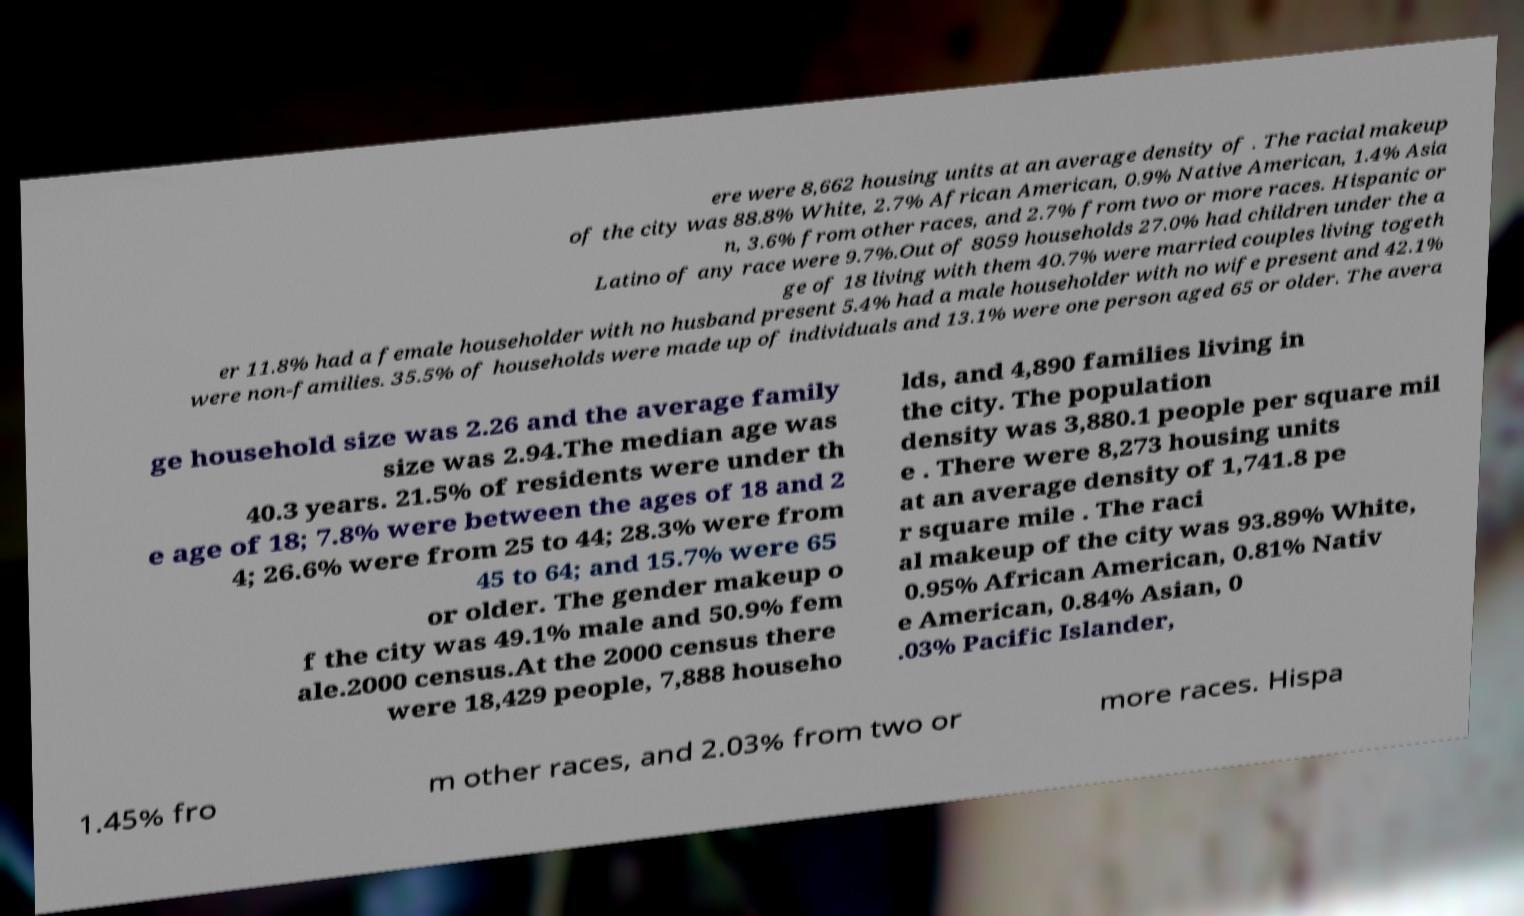What messages or text are displayed in this image? I need them in a readable, typed format. ere were 8,662 housing units at an average density of . The racial makeup of the city was 88.8% White, 2.7% African American, 0.9% Native American, 1.4% Asia n, 3.6% from other races, and 2.7% from two or more races. Hispanic or Latino of any race were 9.7%.Out of 8059 households 27.0% had children under the a ge of 18 living with them 40.7% were married couples living togeth er 11.8% had a female householder with no husband present 5.4% had a male householder with no wife present and 42.1% were non-families. 35.5% of households were made up of individuals and 13.1% were one person aged 65 or older. The avera ge household size was 2.26 and the average family size was 2.94.The median age was 40.3 years. 21.5% of residents were under th e age of 18; 7.8% were between the ages of 18 and 2 4; 26.6% were from 25 to 44; 28.3% were from 45 to 64; and 15.7% were 65 or older. The gender makeup o f the city was 49.1% male and 50.9% fem ale.2000 census.At the 2000 census there were 18,429 people, 7,888 househo lds, and 4,890 families living in the city. The population density was 3,880.1 people per square mil e . There were 8,273 housing units at an average density of 1,741.8 pe r square mile . The raci al makeup of the city was 93.89% White, 0.95% African American, 0.81% Nativ e American, 0.84% Asian, 0 .03% Pacific Islander, 1.45% fro m other races, and 2.03% from two or more races. Hispa 